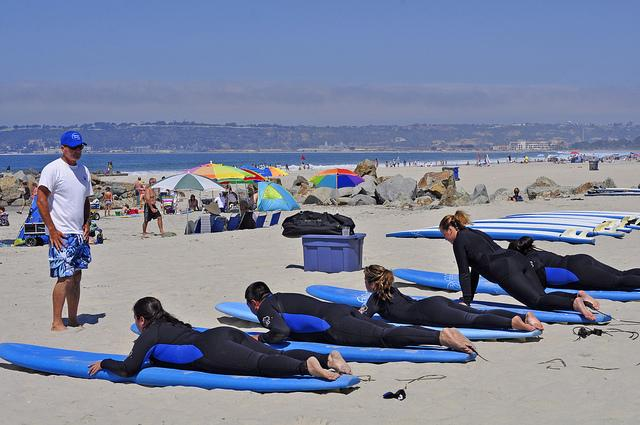What are the people on the blue boards doing? Please explain your reasoning. practicing. People are all on the blue boards practicing to surf. 